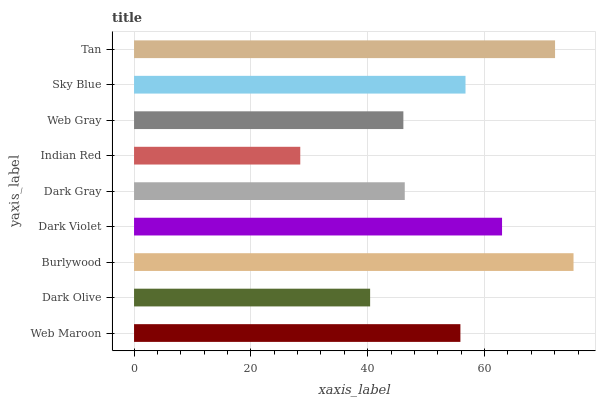Is Indian Red the minimum?
Answer yes or no. Yes. Is Burlywood the maximum?
Answer yes or no. Yes. Is Dark Olive the minimum?
Answer yes or no. No. Is Dark Olive the maximum?
Answer yes or no. No. Is Web Maroon greater than Dark Olive?
Answer yes or no. Yes. Is Dark Olive less than Web Maroon?
Answer yes or no. Yes. Is Dark Olive greater than Web Maroon?
Answer yes or no. No. Is Web Maroon less than Dark Olive?
Answer yes or no. No. Is Web Maroon the high median?
Answer yes or no. Yes. Is Web Maroon the low median?
Answer yes or no. Yes. Is Indian Red the high median?
Answer yes or no. No. Is Dark Olive the low median?
Answer yes or no. No. 